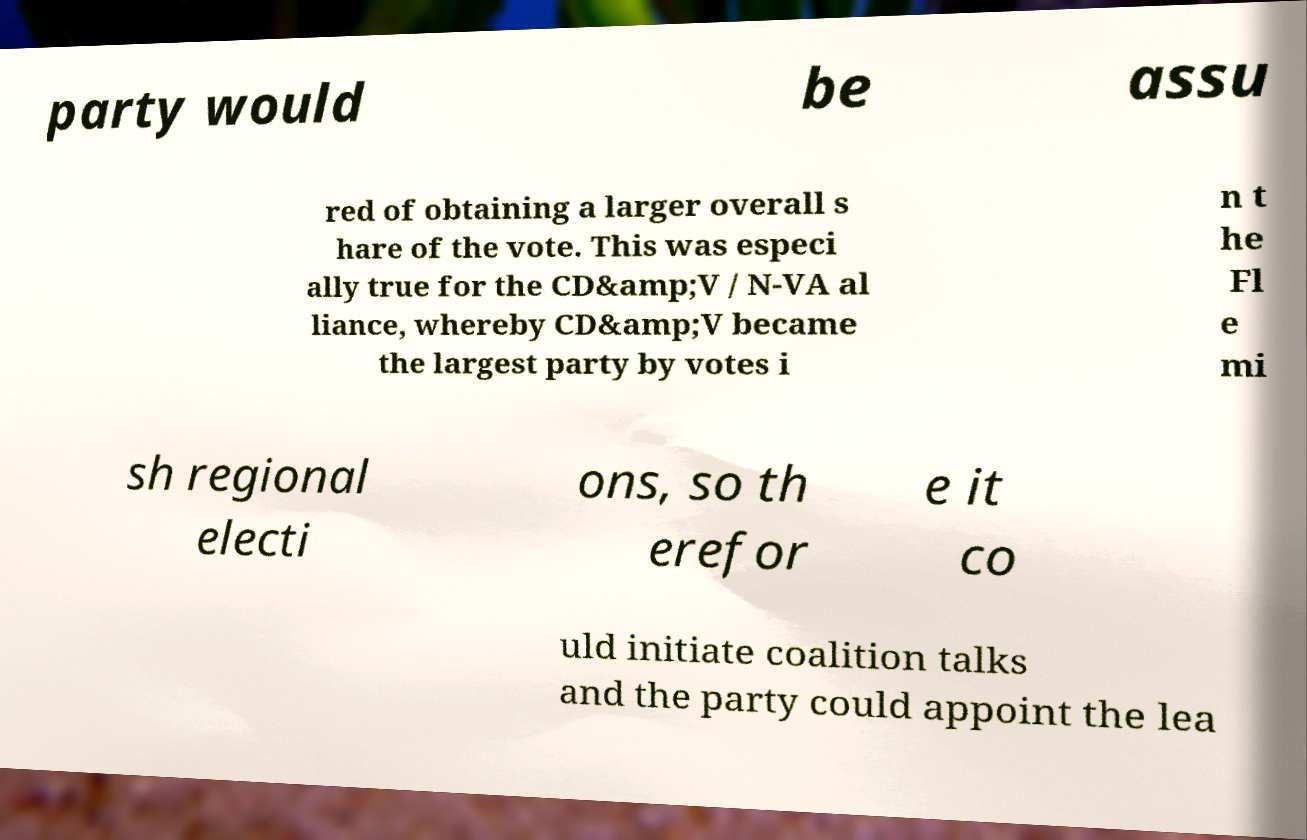For documentation purposes, I need the text within this image transcribed. Could you provide that? party would be assu red of obtaining a larger overall s hare of the vote. This was especi ally true for the CD&amp;V / N-VA al liance, whereby CD&amp;V became the largest party by votes i n t he Fl e mi sh regional electi ons, so th erefor e it co uld initiate coalition talks and the party could appoint the lea 